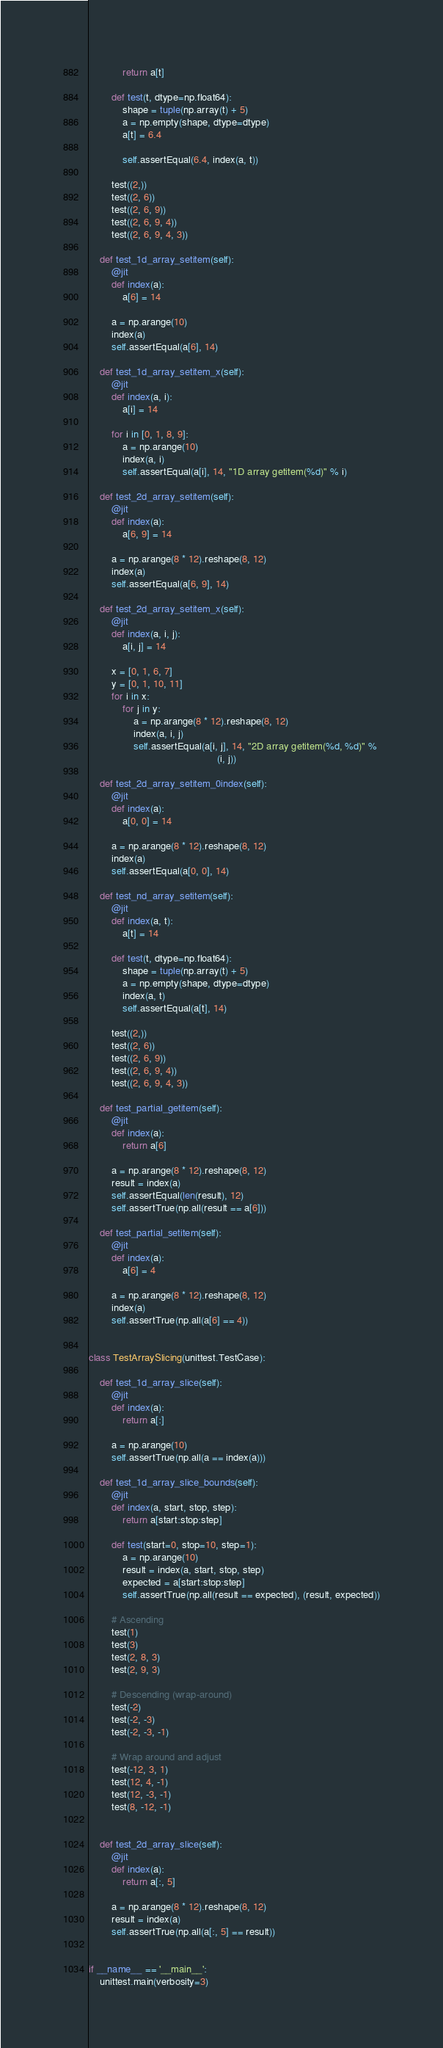<code> <loc_0><loc_0><loc_500><loc_500><_Python_>            return a[t]

        def test(t, dtype=np.float64):
            shape = tuple(np.array(t) + 5)
            a = np.empty(shape, dtype=dtype)
            a[t] = 6.4

            self.assertEqual(6.4, index(a, t))

        test((2,))
        test((2, 6))
        test((2, 6, 9))
        test((2, 6, 9, 4))
        test((2, 6, 9, 4, 3))

    def test_1d_array_setitem(self):
        @jit
        def index(a):
            a[6] = 14

        a = np.arange(10)
        index(a)
        self.assertEqual(a[6], 14)

    def test_1d_array_setitem_x(self):
        @jit
        def index(a, i):
            a[i] = 14

        for i in [0, 1, 8, 9]:
            a = np.arange(10)
            index(a, i)
            self.assertEqual(a[i], 14, "1D array getitem(%d)" % i)

    def test_2d_array_setitem(self):
        @jit
        def index(a):
            a[6, 9] = 14

        a = np.arange(8 * 12).reshape(8, 12)
        index(a)
        self.assertEqual(a[6, 9], 14)

    def test_2d_array_setitem_x(self):
        @jit
        def index(a, i, j):
            a[i, j] = 14

        x = [0, 1, 6, 7]
        y = [0, 1, 10, 11]
        for i in x:
            for j in y:
                a = np.arange(8 * 12).reshape(8, 12)
                index(a, i, j)
                self.assertEqual(a[i, j], 14, "2D array getitem(%d, %d)" %
                                              (i, j))

    def test_2d_array_setitem_0index(self):
        @jit
        def index(a):
            a[0, 0] = 14

        a = np.arange(8 * 12).reshape(8, 12)
        index(a)
        self.assertEqual(a[0, 0], 14)

    def test_nd_array_setitem(self):
        @jit
        def index(a, t):
            a[t] = 14

        def test(t, dtype=np.float64):
            shape = tuple(np.array(t) + 5)
            a = np.empty(shape, dtype=dtype)
            index(a, t)
            self.assertEqual(a[t], 14)

        test((2,))
        test((2, 6))
        test((2, 6, 9))
        test((2, 6, 9, 4))
        test((2, 6, 9, 4, 3))

    def test_partial_getitem(self):
        @jit
        def index(a):
            return a[6]

        a = np.arange(8 * 12).reshape(8, 12)
        result = index(a)
        self.assertEqual(len(result), 12)
        self.assertTrue(np.all(result == a[6]))

    def test_partial_setitem(self):
        @jit
        def index(a):
            a[6] = 4

        a = np.arange(8 * 12).reshape(8, 12)
        index(a)
        self.assertTrue(np.all(a[6] == 4))


class TestArraySlicing(unittest.TestCase):

    def test_1d_array_slice(self):
        @jit
        def index(a):
            return a[:]

        a = np.arange(10)
        self.assertTrue(np.all(a == index(a)))

    def test_1d_array_slice_bounds(self):
        @jit
        def index(a, start, stop, step):
            return a[start:stop:step]

        def test(start=0, stop=10, step=1):
            a = np.arange(10)
            result = index(a, start, stop, step)
            expected = a[start:stop:step]
            self.assertTrue(np.all(result == expected), (result, expected))

        # Ascending
        test(1)
        test(3)
        test(2, 8, 3)
        test(2, 9, 3)

        # Descending (wrap-around)
        test(-2)
        test(-2, -3)
        test(-2, -3, -1)

        # Wrap around and adjust
        test(-12, 3, 1)
        test(12, 4, -1)
        test(12, -3, -1)
        test(8, -12, -1)


    def test_2d_array_slice(self):
        @jit
        def index(a):
            return a[:, 5]

        a = np.arange(8 * 12).reshape(8, 12)
        result = index(a)
        self.assertTrue(np.all(a[:, 5] == result))


if __name__ == '__main__':
    unittest.main(verbosity=3)</code> 